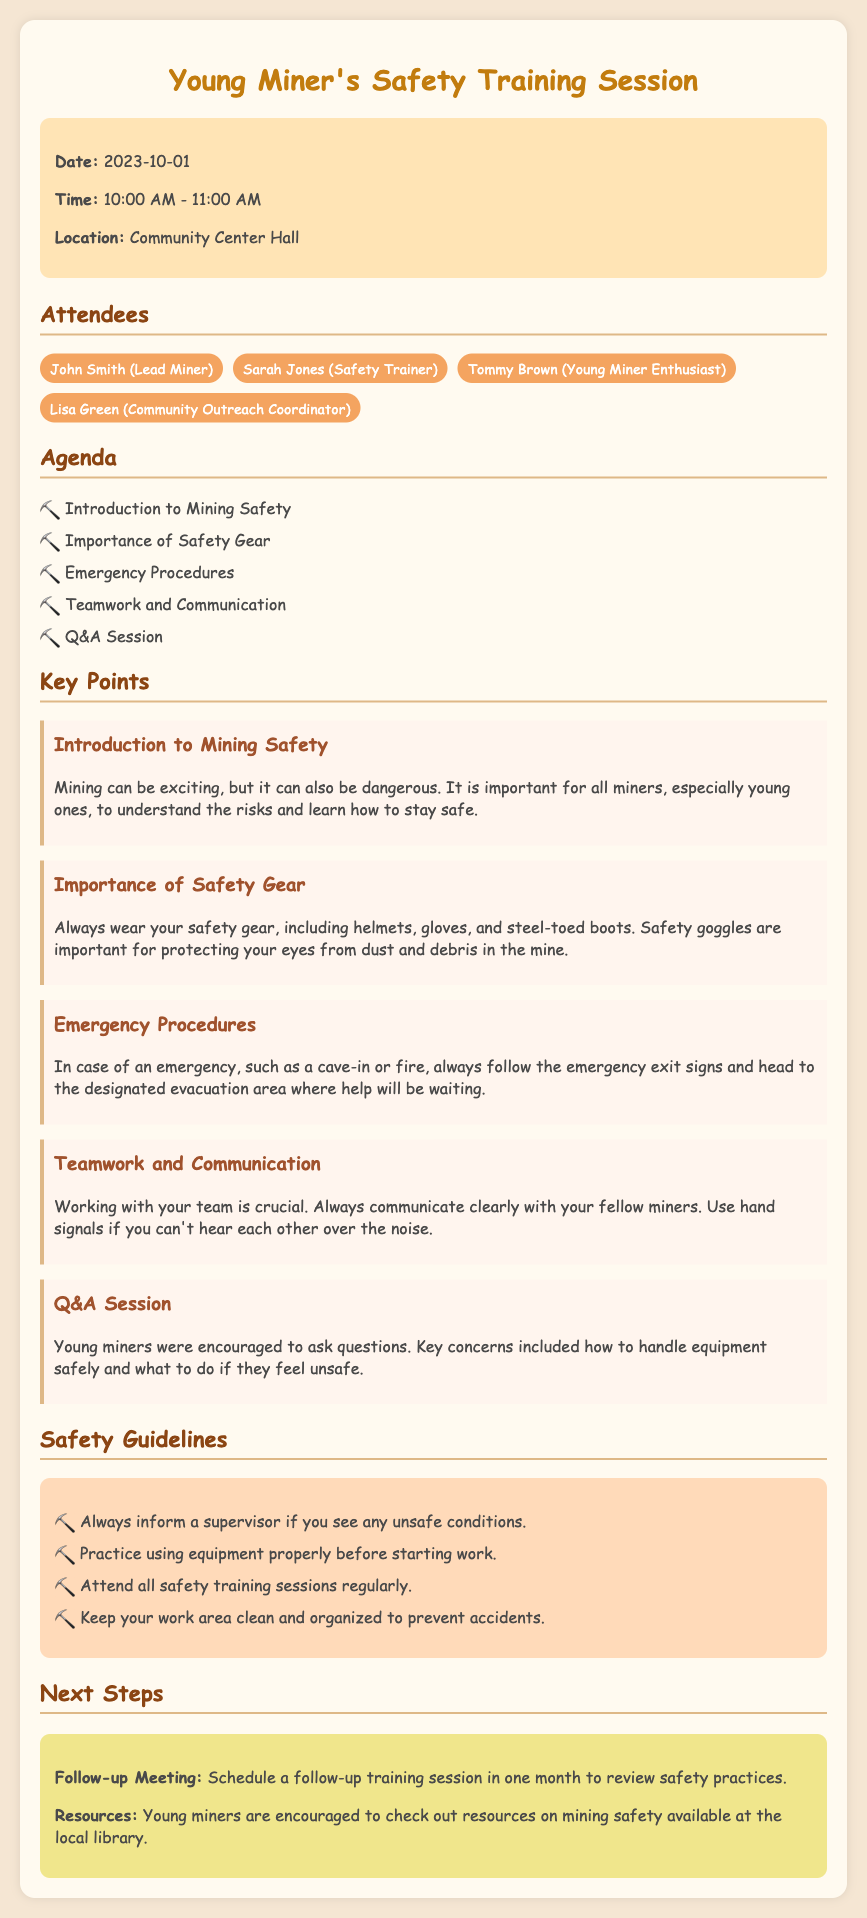What is the date of the safety training session? The date is mentioned in the document under the info box section.
Answer: 2023-10-01 Who was the lead miner present at the meeting? The document lists the attendees, and John Smith is mentioned as the lead miner.
Answer: John Smith What are young miners encouraged to do in case of an emergency? This information is discussed in the key points section about emergency procedures.
Answer: Follow the emergency exit signs How many attendees were listed in the document? The number of attendees is counted in the attendees section of the document.
Answer: Four What should miners always wear for safety? This is covered under the key points section discussing safety gear.
Answer: Safety gear What will be scheduled in one month? The next steps section mentions future arrangements.
Answer: Follow-up training session What is one guideline for young miners listed in the document? The guidelines section lists important practices for safety.
Answer: Inform a supervisor What communication method is suggested if miners can't hear each other? The reasoning can be derived from key points on teamwork and communication.
Answer: Hand signals 